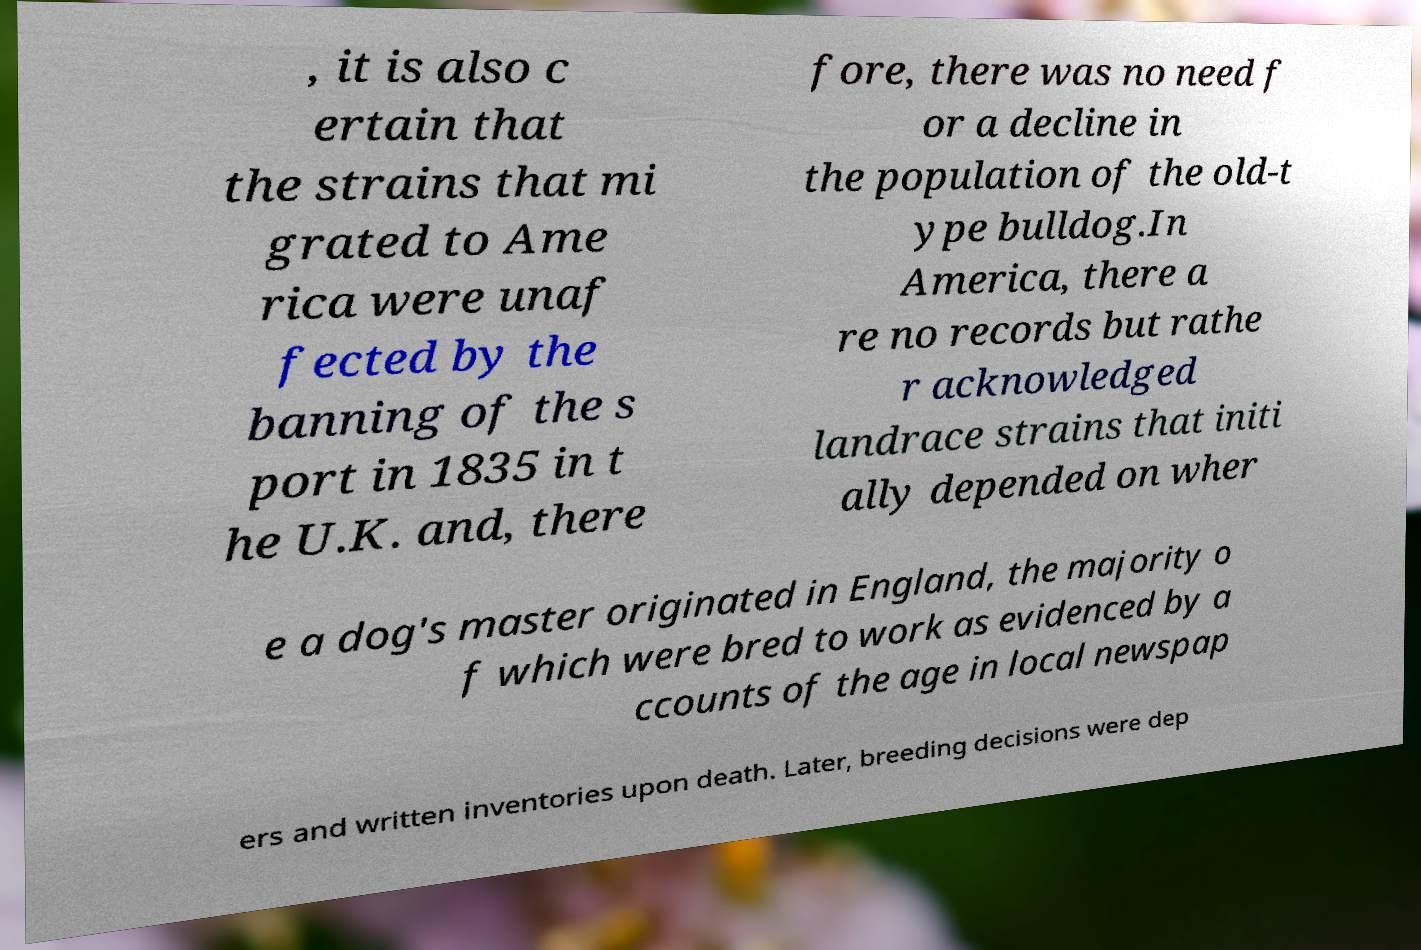Please identify and transcribe the text found in this image. , it is also c ertain that the strains that mi grated to Ame rica were unaf fected by the banning of the s port in 1835 in t he U.K. and, there fore, there was no need f or a decline in the population of the old-t ype bulldog.In America, there a re no records but rathe r acknowledged landrace strains that initi ally depended on wher e a dog's master originated in England, the majority o f which were bred to work as evidenced by a ccounts of the age in local newspap ers and written inventories upon death. Later, breeding decisions were dep 